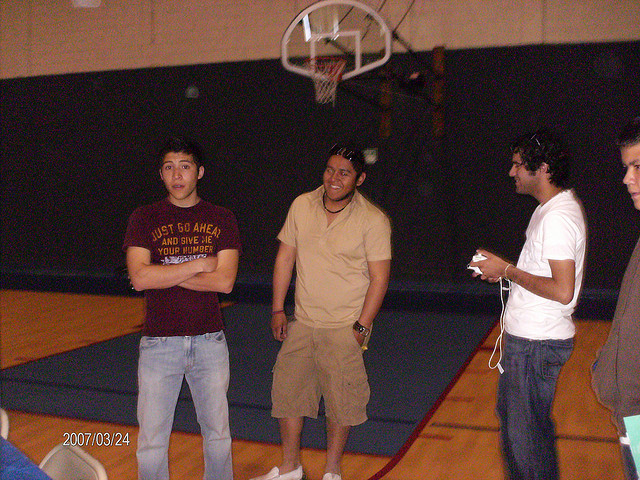Can you tell me more about their environment? Certainly! The image depicts an indoor basketball court, identifiable by the shiny wooden flooring, boundary lines for the court, and the basketball hoop. The lighting suggests the space is well-lit, typical for an indoor sports facility to ensure clear visibility during games. 